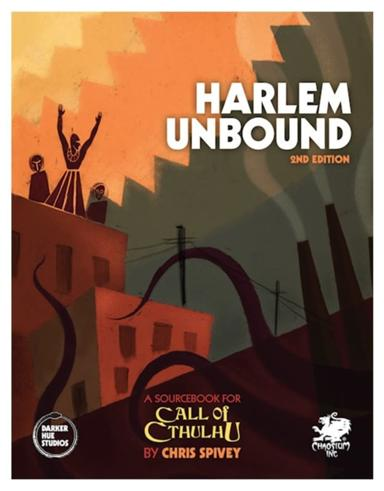Can you tell me more about the significance of the cover art design for 'Harlem Unbound'? The cover art of 'Harlem Unbound' is symbolic, portraying the vibrant cultural scene of Harlem with a backdrop of an ominous, larger-than-life figure. This pairing hints at the intertwining of the ordinary and the supernatural that players can expect in the game. The use of vibrant colors suggests the lively, artistic vigor of the Harlem Renaissance, contrasted against the looming, shadowy figures that nod to the mysterious and eerie adventures that lie within. 